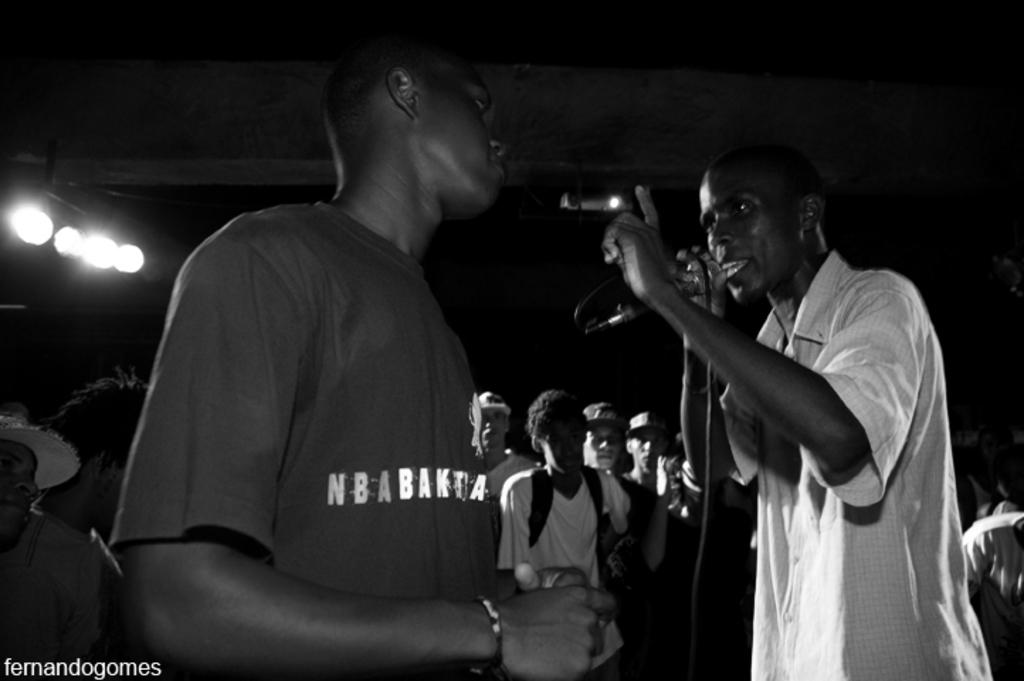What is happening on the right side of the image? There is a person standing on the right side of the image, and they are speaking in front of a microphone. Who is the person on the right speaking to? There is another person standing in front of the person on the right. What can be seen in the background of the image? There is a group of people in the background of the image. What type of shelf can be seen behind the person on the right? There is no shelf visible in the image. Is there a beggar present in the image? There is no beggar present in the image. 